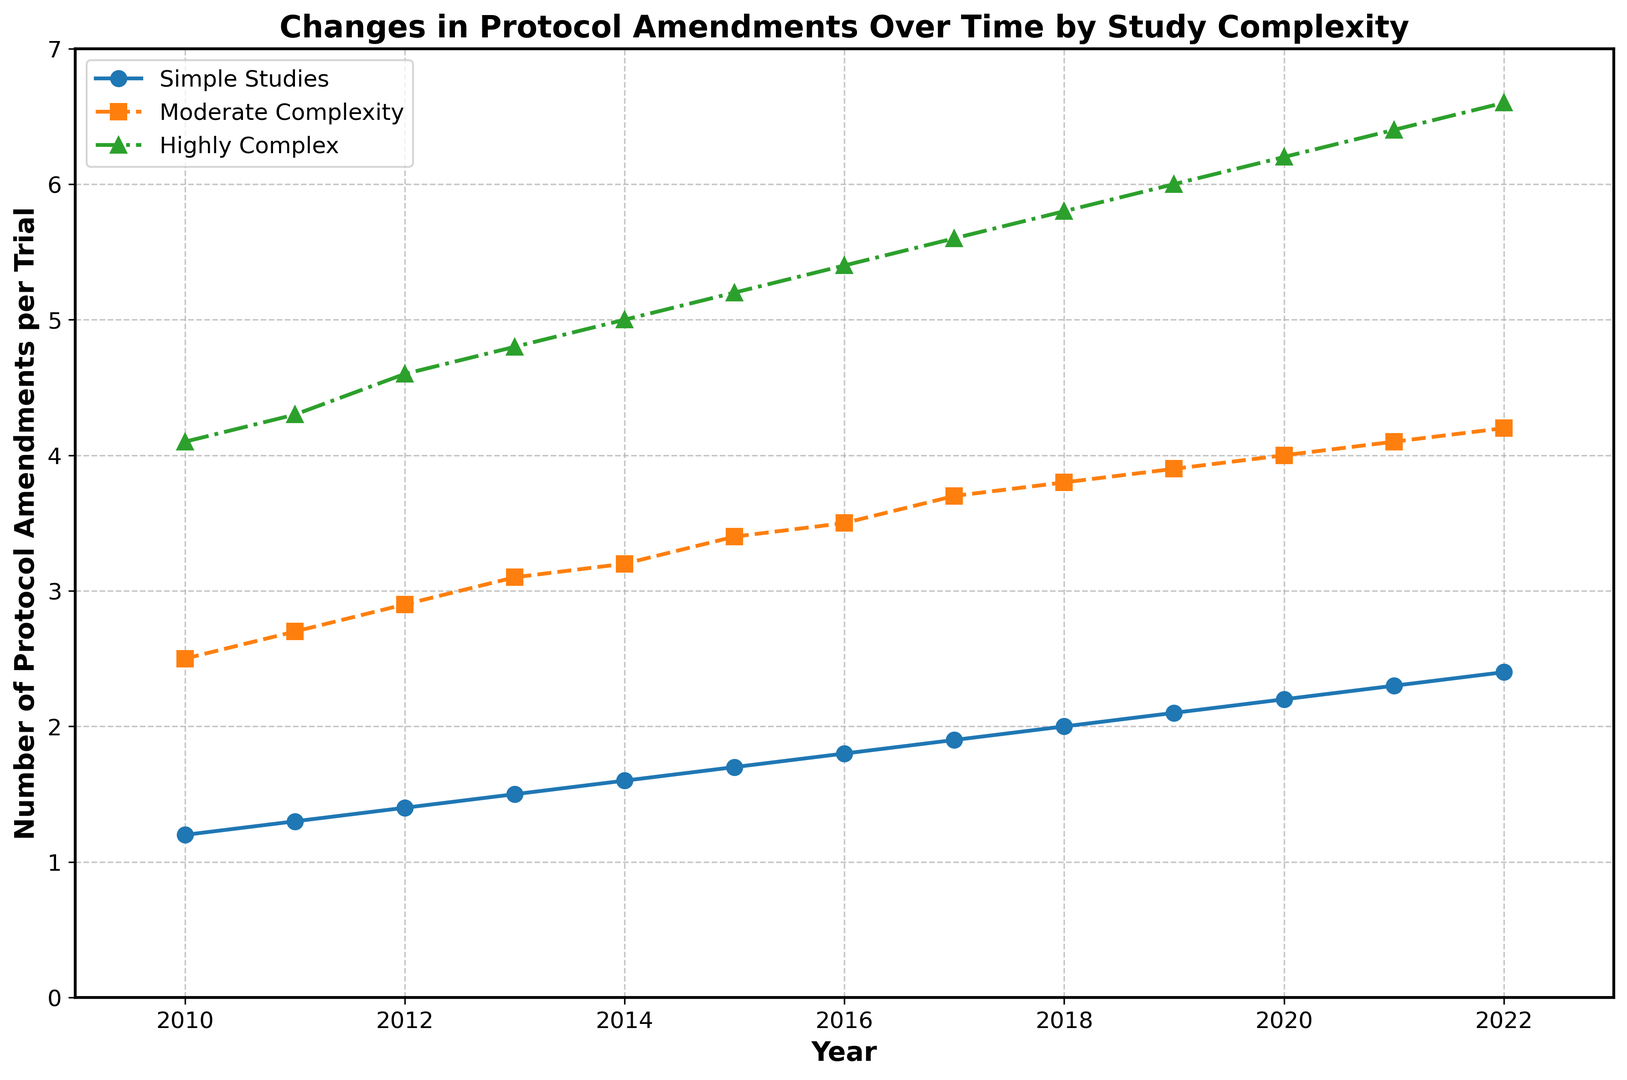Which year shows the highest number of protocol amendments for highly complex studies? Look at the green line representing highly complex studies and identify the year with the highest y-value, which occurs in 2022.
Answer: 2022 Compare the number of protocol amendments for simple and moderate complexity studies in 2018. Which had more amendments? Check the y-values of the blue line for simple studies and the orange dashed line for moderate complexity studies in 2018. Simple has 2.0 and moderate has 3.8.
Answer: Moderate Complexity What is the average number of protocol amendments for highly complex studies in 2015 and 2016? Add the y-values of the green line for highly complex studies in 2015 and 2016, which are 5.2 and 5.4, then divide by 2: (5.2 + 5.4) / 2.
Answer: 5.3 In which year did simple studies first reach an average of more than 2 protocol amendments per trial? Locate the point on the blue line where the y-value first exceeds 2. This happens in 2018.
Answer: 2018 How much did the number of protocol amendments increase for moderate complexity studies from 2013 to 2020? Subtract the y-values of the orange dashed line in 2020 (4.0) and 2013 (3.1): 4.0 - 3.1.
Answer: 0.9 Which category had the smallest increase in protocol amendments from 2010 to 2022? Calculate the difference between 2022 and 2010 for each category: Simple (2.4 - 1.2 = 1.2), Moderate (4.2 - 2.5 = 1.7), Highly Complex (6.6 - 4.1 = 2.5). The smallest increase is for Simple Studies.
Answer: Simple Studies How many years did it take for moderate complexity studies to reach 4 protocol amendments per trial starting from 2010? Identify the year when the orange dashed line for moderate complexity studies reaches 4, which occurs in 2020. Subtract 2010 from 2020.
Answer: 10 Compare the trends for simple and highly complex studies. Which category shows a steeper increase in the number of protocol amendments from 2010 to 2022? Analyze the slopes of the blue line (simple studies: increase of 1.2) and the green line (highly complex studies: increase of 2.5). The green line for highly complex studies has a steeper increase.
Answer: Highly Complex What is the total number of protocol amendments for simple studies in 2010 and 2022 combined? Add the y-values of the blue line for simple studies in 2010 (1.2) and 2022 (2.4): 1.2 + 2.4.
Answer: 3.6 Which category had the steepest linear increase between 2010 and 2013? Calculate the slope for each category between 2010 and 2013: Simple [(1.5-1.2)/3=0.1], Moderate[(3.1-2.5)/3=0.2], Highly Complex[(4.8-4.1)/3=0.233]. The steepest increase is for Highly Complex studies.
Answer: Highly Complex 